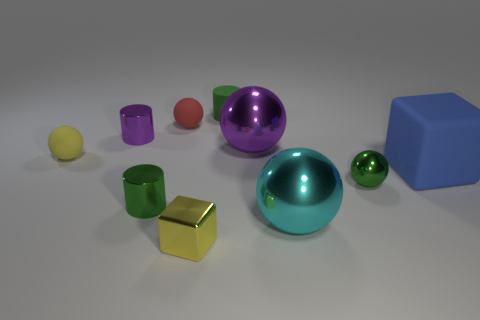Is the number of cyan shiny balls that are on the right side of the purple metallic sphere greater than the number of large cylinders?
Ensure brevity in your answer.  Yes. Is the shape of the yellow object on the right side of the yellow sphere the same as  the big blue rubber thing?
Ensure brevity in your answer.  Yes. How many things are tiny green cylinders or small balls that are to the right of the small green metallic cylinder?
Provide a succinct answer. 4. There is a cylinder that is behind the blue matte cube and to the right of the purple metallic cylinder; what is its size?
Your answer should be very brief. Small. Are there more green cylinders that are in front of the tiny purple metallic thing than large purple metal spheres behind the large purple sphere?
Your response must be concise. Yes. There is a large rubber object; is its shape the same as the tiny yellow thing that is in front of the small green ball?
Your answer should be very brief. Yes. What number of other things are the same shape as the tiny purple object?
Give a very brief answer. 2. There is a matte object that is both on the left side of the small matte cylinder and behind the purple shiny cylinder; what is its color?
Your response must be concise. Red. What color is the matte cylinder?
Ensure brevity in your answer.  Green. Are the large cyan sphere and the small yellow thing that is behind the large cyan ball made of the same material?
Make the answer very short. No. 